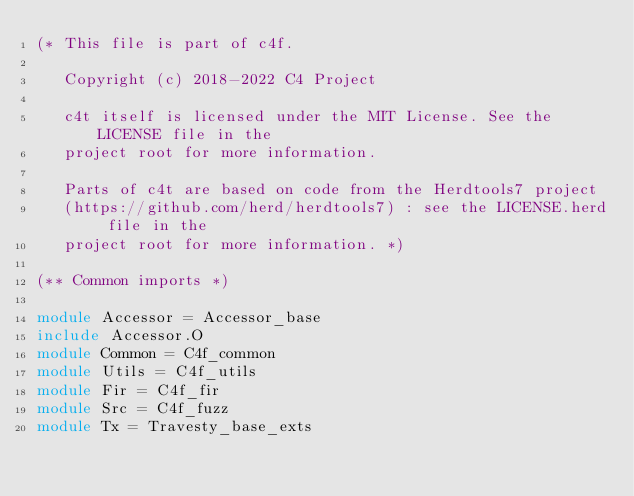Convert code to text. <code><loc_0><loc_0><loc_500><loc_500><_OCaml_>(* This file is part of c4f.

   Copyright (c) 2018-2022 C4 Project

   c4t itself is licensed under the MIT License. See the LICENSE file in the
   project root for more information.

   Parts of c4t are based on code from the Herdtools7 project
   (https://github.com/herd/herdtools7) : see the LICENSE.herd file in the
   project root for more information. *)

(** Common imports *)

module Accessor = Accessor_base
include Accessor.O
module Common = C4f_common
module Utils = C4f_utils
module Fir = C4f_fir
module Src = C4f_fuzz
module Tx = Travesty_base_exts
</code> 